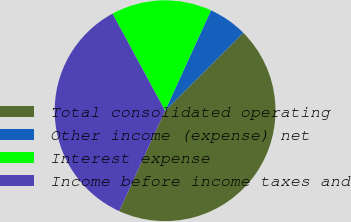Convert chart. <chart><loc_0><loc_0><loc_500><loc_500><pie_chart><fcel>Total consolidated operating<fcel>Other income (expense) net<fcel>Interest expense<fcel>Income before income taxes and<nl><fcel>44.29%<fcel>5.71%<fcel>14.73%<fcel>35.27%<nl></chart> 